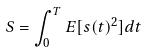Convert formula to latex. <formula><loc_0><loc_0><loc_500><loc_500>S = \int _ { 0 } ^ { T } E [ s ( t ) ^ { 2 } ] d t</formula> 